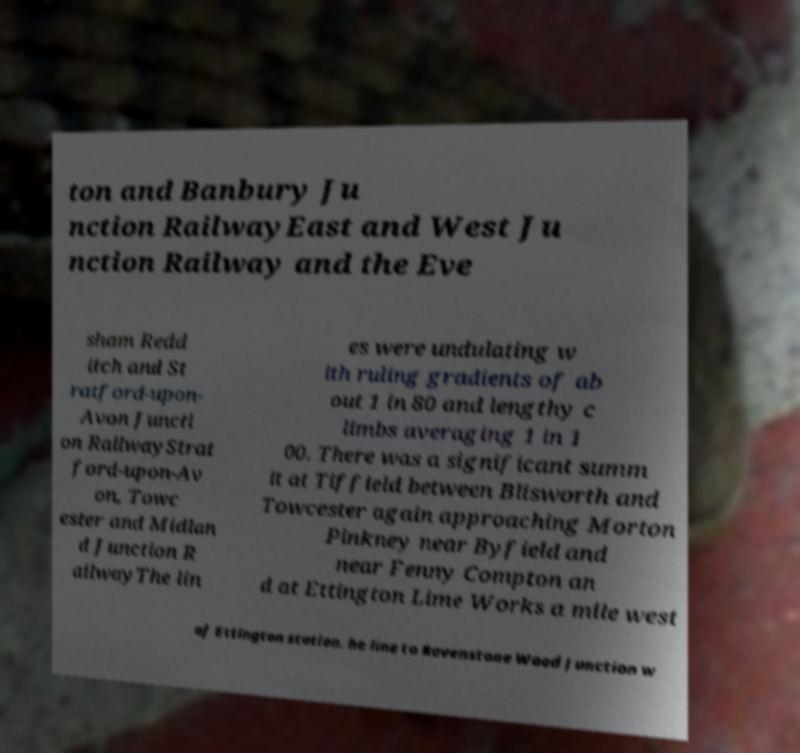Can you accurately transcribe the text from the provided image for me? ton and Banbury Ju nction RailwayEast and West Ju nction Railway and the Eve sham Redd itch and St ratford-upon- Avon Juncti on RailwayStrat ford-upon-Av on, Towc ester and Midlan d Junction R ailwayThe lin es were undulating w ith ruling gradients of ab out 1 in 80 and lengthy c limbs averaging 1 in 1 00. There was a significant summ it at Tiffield between Blisworth and Towcester again approaching Morton Pinkney near Byfield and near Fenny Compton an d at Ettington Lime Works a mile west of Ettington station. he line to Ravenstone Wood Junction w 